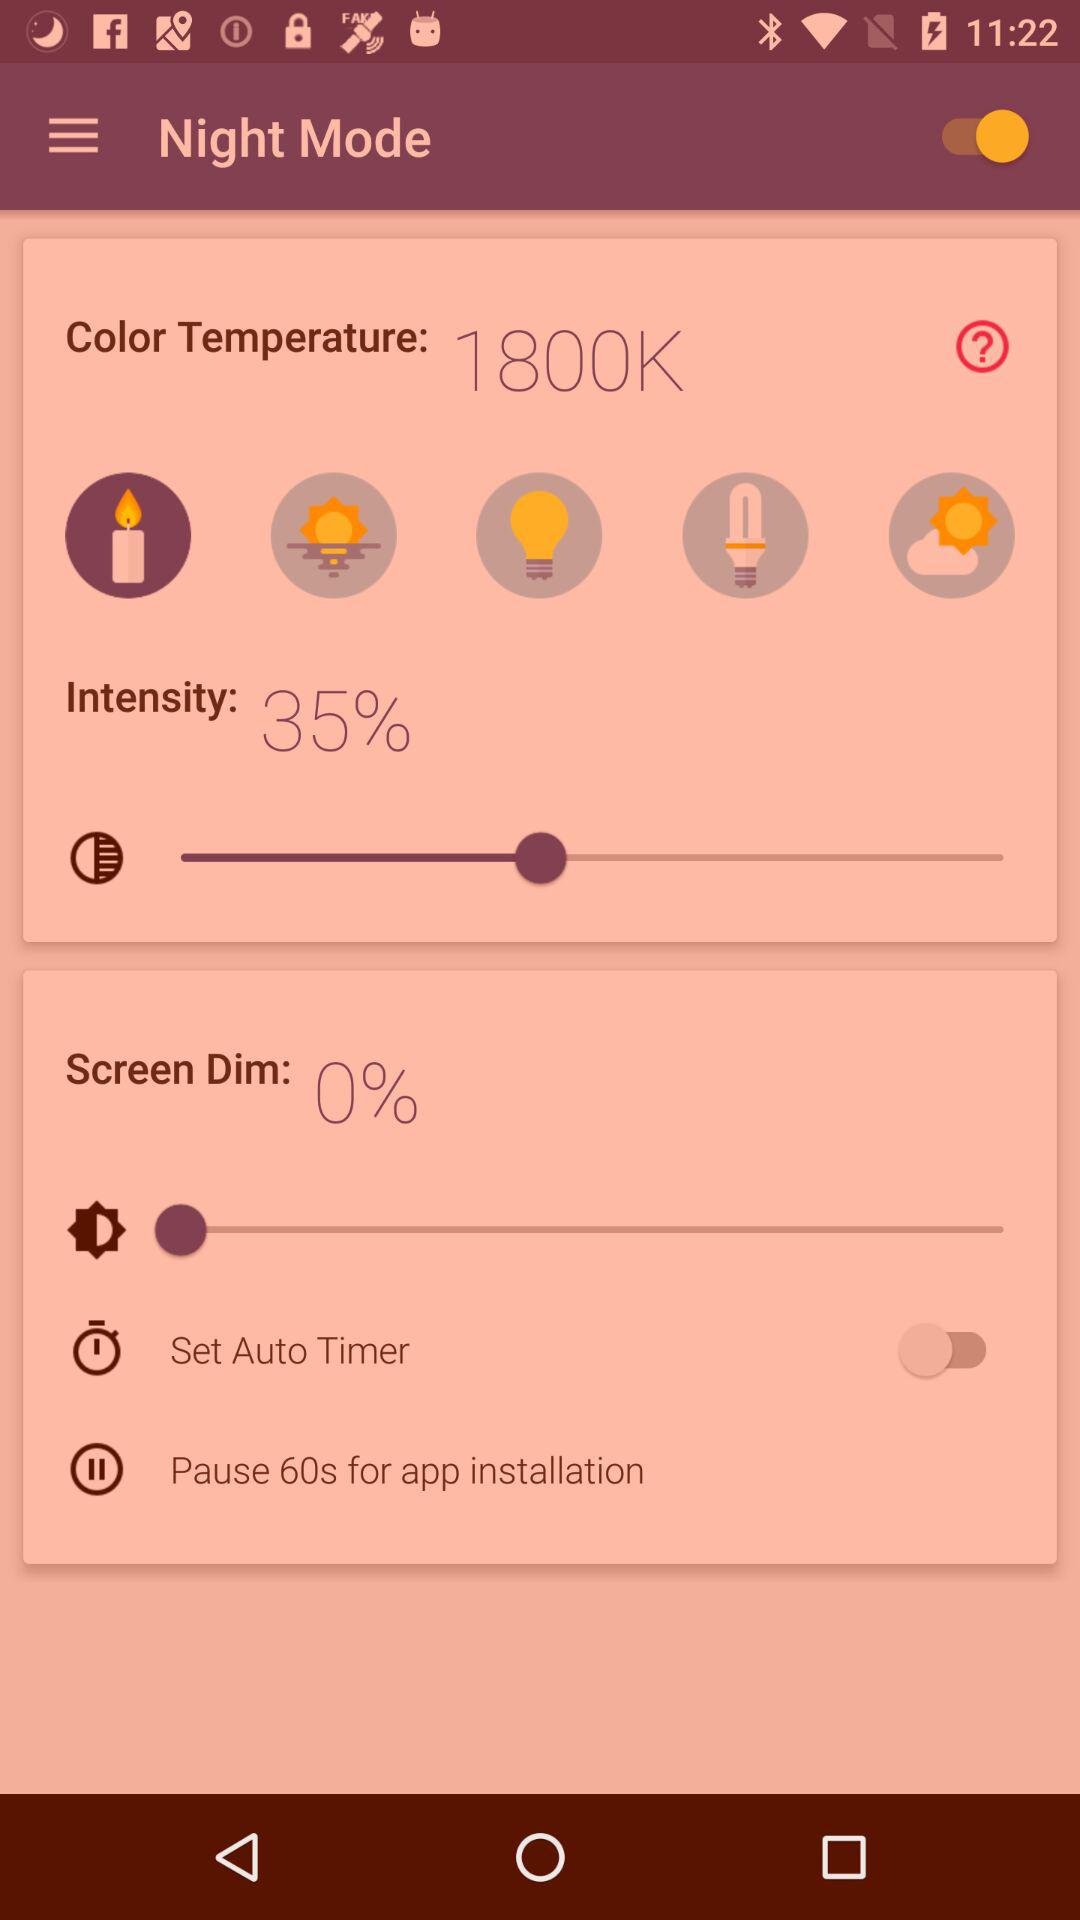What is the pause time for application installation? The pause time for application installation is 60 seconds. 